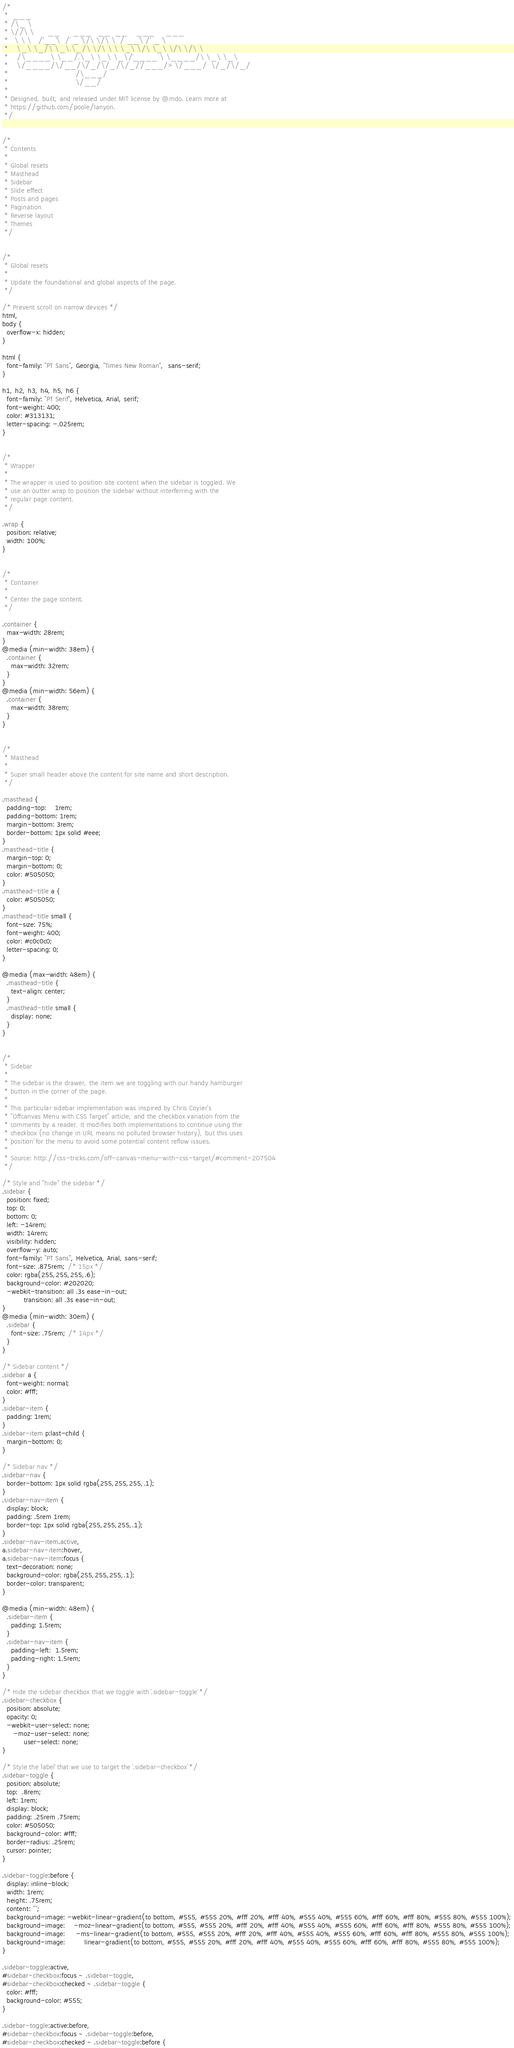<code> <loc_0><loc_0><loc_500><loc_500><_CSS_>/*
 *  ___
 * /\_ \
 * \//\ \      __      ___   __  __    ___     ___
 *   \ \ \   /'__`\  /' _ `\/\ \/\ \  / __`\ /' _ `\
 *    \_\ \_/\ \_\.\_/\ \/\ \ \ \_\ \/\ \_\ \/\ \/\ \
 *    /\____\ \__/.\_\ \_\ \_\/`____ \ \____/\ \_\ \_\
 *    \/____/\/__/\/_/\/_/\/_/`/___/> \/___/  \/_/\/_/
 *                               /\___/
 *                               \/__/
 *
 * Designed, built, and released under MIT license by @mdo. Learn more at
 * https://github.com/poole/lanyon.
 */


/*
 * Contents
 *
 * Global resets
 * Masthead
 * Sidebar
 * Slide effect
 * Posts and pages
 * Pagination
 * Reverse layout
 * Themes
 */


/*
 * Global resets
 *
 * Update the foundational and global aspects of the page.
 */

/* Prevent scroll on narrow devices */
html,
body {
  overflow-x: hidden;
}

html {
  font-family: "PT Sans", Georgia, "Times New Roman",  sans-serif;
}

h1, h2, h3, h4, h5, h6 {
  font-family: "PT Serif", Helvetica, Arial, serif;
  font-weight: 400;
  color: #313131;
  letter-spacing: -.025rem;
}


/*
 * Wrapper
 *
 * The wrapper is used to position site content when the sidebar is toggled. We
 * use an outter wrap to position the sidebar without interferring with the
 * regular page content.
 */

.wrap {
  position: relative;
  width: 100%;
}


/*
 * Container
 *
 * Center the page content.
 */

.container {
  max-width: 28rem;
}
@media (min-width: 38em) {
  .container {
    max-width: 32rem;
  }
}
@media (min-width: 56em) {
  .container {
    max-width: 38rem;
  }
}


/*
 * Masthead
 *
 * Super small header above the content for site name and short description.
 */

.masthead {
  padding-top:    1rem;
  padding-bottom: 1rem;
  margin-bottom: 3rem;
  border-bottom: 1px solid #eee;
}
.masthead-title {
  margin-top: 0;
  margin-bottom: 0;
  color: #505050;
}
.masthead-title a {
  color: #505050;
}
.masthead-title small {
  font-size: 75%;
  font-weight: 400;
  color: #c0c0c0;
  letter-spacing: 0;
}

@media (max-width: 48em) {
  .masthead-title {
    text-align: center;
  }
  .masthead-title small {
    display: none;
  }
}


/*
 * Sidebar
 *
 * The sidebar is the drawer, the item we are toggling with our handy hamburger
 * button in the corner of the page.
 *
 * This particular sidebar implementation was inspired by Chris Coyier's
 * "Offcanvas Menu with CSS Target" article, and the checkbox variation from the
 * comments by a reader. It modifies both implementations to continue using the
 * checkbox (no change in URL means no polluted browser history), but this uses
 * `position` for the menu to avoid some potential content reflow issues.
 *
 * Source: http://css-tricks.com/off-canvas-menu-with-css-target/#comment-207504
 */

/* Style and "hide" the sidebar */
.sidebar {
  position: fixed;
  top: 0;
  bottom: 0;
  left: -14rem;
  width: 14rem;
  visibility: hidden;
  overflow-y: auto;
  font-family: "PT Sans", Helvetica, Arial, sans-serif;
  font-size: .875rem; /* 15px */
  color: rgba(255,255,255,.6);
  background-color: #202020;
  -webkit-transition: all .3s ease-in-out;
          transition: all .3s ease-in-out;
}
@media (min-width: 30em) {
  .sidebar {
    font-size: .75rem; /* 14px */
  }
}

/* Sidebar content */
.sidebar a {
  font-weight: normal;
  color: #fff;
}
.sidebar-item {
  padding: 1rem;
}
.sidebar-item p:last-child {
  margin-bottom: 0;
}

/* Sidebar nav */
.sidebar-nav {
  border-bottom: 1px solid rgba(255,255,255,.1);
}
.sidebar-nav-item {
  display: block;
  padding: .5rem 1rem;
  border-top: 1px solid rgba(255,255,255,.1);
}
.sidebar-nav-item.active,
a.sidebar-nav-item:hover,
a.sidebar-nav-item:focus {
  text-decoration: none;
  background-color: rgba(255,255,255,.1);
  border-color: transparent;
}

@media (min-width: 48em) {
  .sidebar-item {
    padding: 1.5rem;
  }
  .sidebar-nav-item {
    padding-left:  1.5rem;
    padding-right: 1.5rem;
  }
}

/* Hide the sidebar checkbox that we toggle with `.sidebar-toggle` */
.sidebar-checkbox {
  position: absolute;
  opacity: 0;
  -webkit-user-select: none;
     -moz-user-select: none;
          user-select: none;
}

/* Style the `label` that we use to target the `.sidebar-checkbox` */
.sidebar-toggle {
  position: absolute;
  top:  .8rem;
  left: 1rem;
  display: block;
  padding: .25rem .75rem;
  color: #505050;
  background-color: #fff;
  border-radius: .25rem;
  cursor: pointer;
}

.sidebar-toggle:before {
  display: inline-block;
  width: 1rem;
  height: .75rem;
  content: "";
  background-image: -webkit-linear-gradient(to bottom, #555, #555 20%, #fff 20%, #fff 40%, #555 40%, #555 60%, #fff 60%, #fff 80%, #555 80%, #555 100%);
  background-image:    -moz-linear-gradient(to bottom, #555, #555 20%, #fff 20%, #fff 40%, #555 40%, #555 60%, #fff 60%, #fff 80%, #555 80%, #555 100%);
  background-image:     -ms-linear-gradient(to bottom, #555, #555 20%, #fff 20%, #fff 40%, #555 40%, #555 60%, #fff 60%, #fff 80%, #555 80%, #555 100%);
  background-image:         linear-gradient(to bottom, #555, #555 20%, #fff 20%, #fff 40%, #555 40%, #555 60%, #fff 60%, #fff 80%, #555 80%, #555 100%);
}

.sidebar-toggle:active,
#sidebar-checkbox:focus ~ .sidebar-toggle,
#sidebar-checkbox:checked ~ .sidebar-toggle {
  color: #fff;
  background-color: #555;
}

.sidebar-toggle:active:before,
#sidebar-checkbox:focus ~ .sidebar-toggle:before,
#sidebar-checkbox:checked ~ .sidebar-toggle:before {</code> 